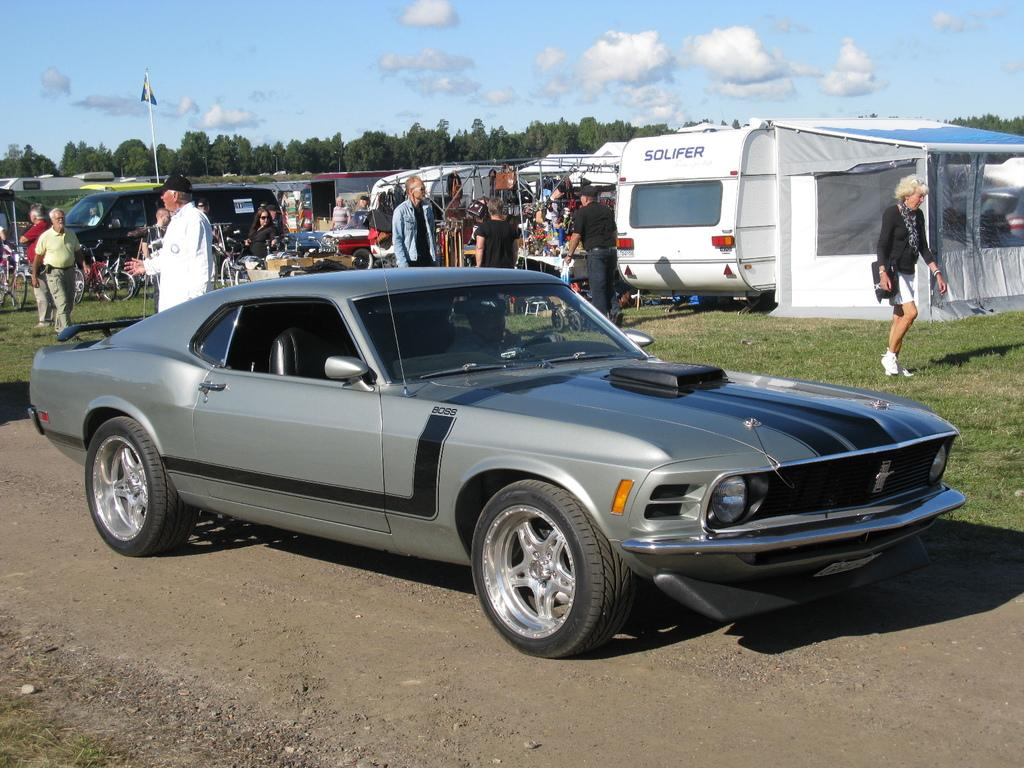What types of living organisms can be seen in the image? People and trees are visible in the image. What else can be seen in the image besides living organisms? Vehicles, grass, a tent, objects, a flag on a pole, and the sky with clouds are visible in the image. Can you describe the setting where the people and vehicles are located? The setting appears to be outdoors, with grass, trees, and a tent present. What is the weather like in the image? The presence of clouds in the sky suggests that it might be partly cloudy. What rule does the spy follow while interacting with the stranger in the image? There is no spy or stranger present in the image, so no such interaction can be observed. 